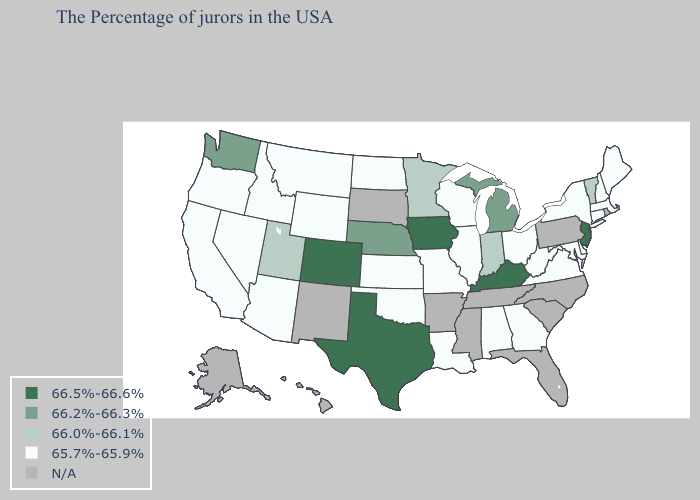Which states have the lowest value in the USA?
Keep it brief. Maine, Massachusetts, New Hampshire, Connecticut, New York, Delaware, Maryland, Virginia, West Virginia, Ohio, Georgia, Alabama, Wisconsin, Illinois, Louisiana, Missouri, Kansas, Oklahoma, North Dakota, Wyoming, Montana, Arizona, Idaho, Nevada, California, Oregon. What is the lowest value in the South?
Concise answer only. 65.7%-65.9%. Does Oklahoma have the lowest value in the South?
Answer briefly. Yes. Which states have the lowest value in the USA?
Quick response, please. Maine, Massachusetts, New Hampshire, Connecticut, New York, Delaware, Maryland, Virginia, West Virginia, Ohio, Georgia, Alabama, Wisconsin, Illinois, Louisiana, Missouri, Kansas, Oklahoma, North Dakota, Wyoming, Montana, Arizona, Idaho, Nevada, California, Oregon. Which states have the lowest value in the USA?
Concise answer only. Maine, Massachusetts, New Hampshire, Connecticut, New York, Delaware, Maryland, Virginia, West Virginia, Ohio, Georgia, Alabama, Wisconsin, Illinois, Louisiana, Missouri, Kansas, Oklahoma, North Dakota, Wyoming, Montana, Arizona, Idaho, Nevada, California, Oregon. Which states have the lowest value in the MidWest?
Quick response, please. Ohio, Wisconsin, Illinois, Missouri, Kansas, North Dakota. What is the value of Illinois?
Quick response, please. 65.7%-65.9%. Name the states that have a value in the range 66.2%-66.3%?
Answer briefly. Michigan, Nebraska, Washington. How many symbols are there in the legend?
Be succinct. 5. Does the map have missing data?
Short answer required. Yes. Name the states that have a value in the range 66.2%-66.3%?
Keep it brief. Michigan, Nebraska, Washington. Does the first symbol in the legend represent the smallest category?
Quick response, please. No. What is the value of Arizona?
Quick response, please. 65.7%-65.9%. Which states have the highest value in the USA?
Keep it brief. New Jersey, Kentucky, Iowa, Texas, Colorado. 